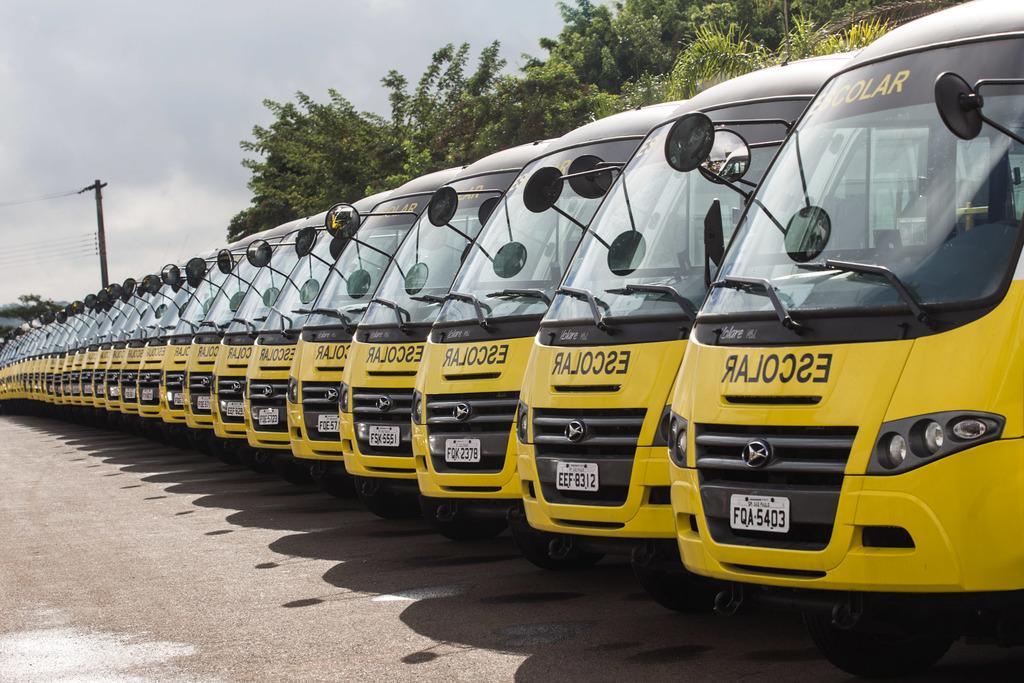Could you give a brief overview of what you see in this image? In this image I can see few buses. They are in black and yellow color. I can see few number-plates,trees,current poles and wires. The sky is in white and blue color. 